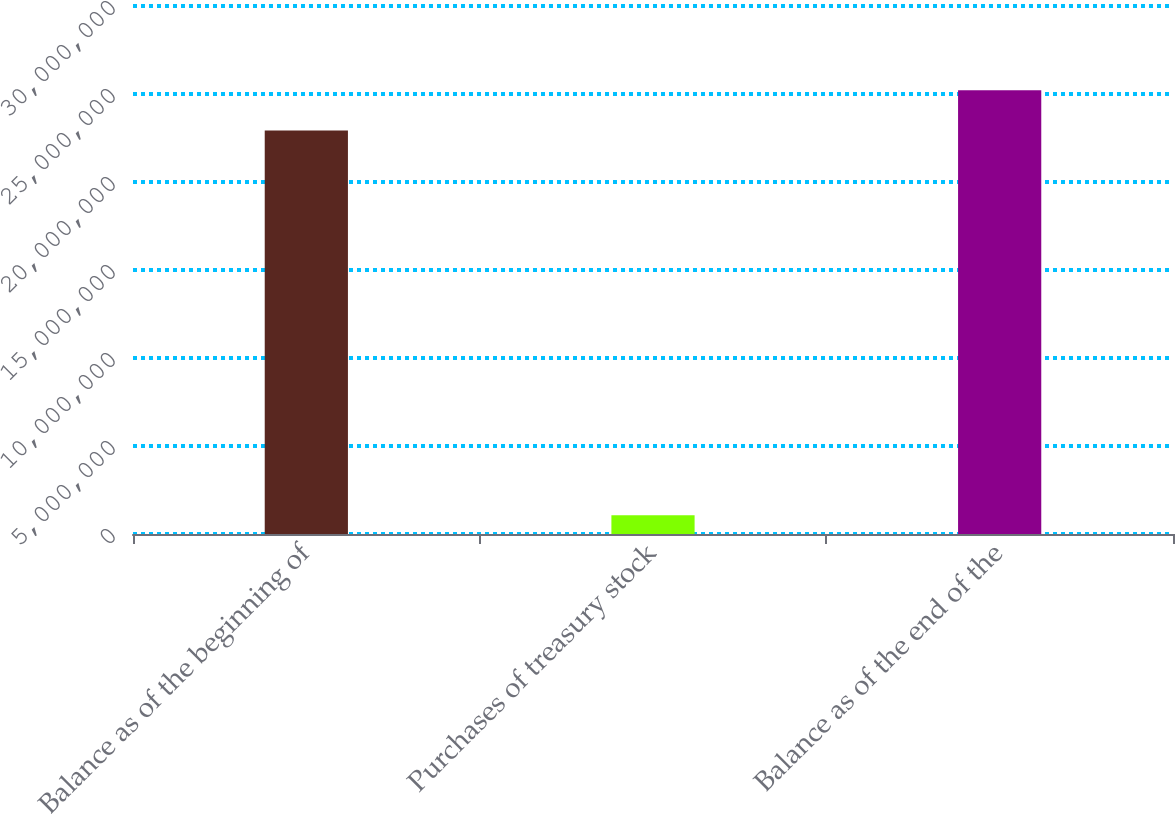Convert chart. <chart><loc_0><loc_0><loc_500><loc_500><bar_chart><fcel>Balance as of the beginning of<fcel>Purchases of treasury stock<fcel>Balance as of the end of the<nl><fcel>2.29213e+07<fcel>1.06554e+06<fcel>2.52134e+07<nl></chart> 